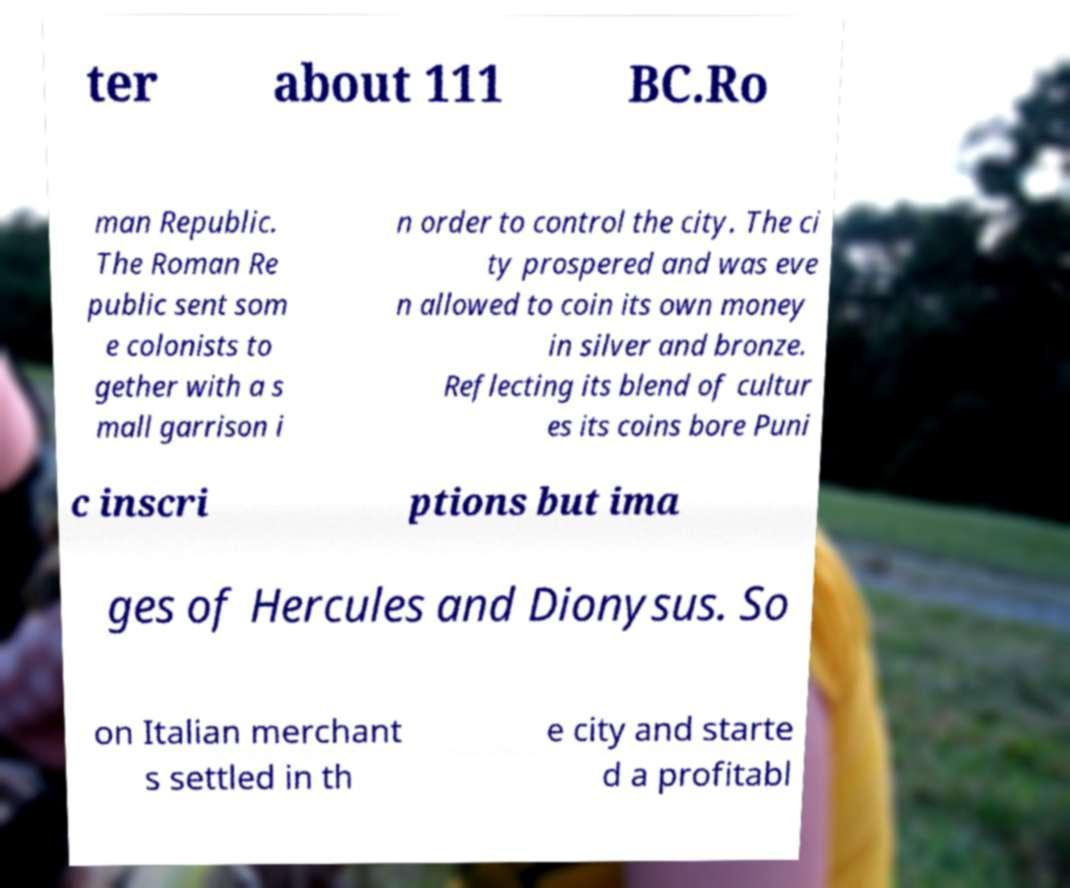For documentation purposes, I need the text within this image transcribed. Could you provide that? ter about 111 BC.Ro man Republic. The Roman Re public sent som e colonists to gether with a s mall garrison i n order to control the city. The ci ty prospered and was eve n allowed to coin its own money in silver and bronze. Reflecting its blend of cultur es its coins bore Puni c inscri ptions but ima ges of Hercules and Dionysus. So on Italian merchant s settled in th e city and starte d a profitabl 